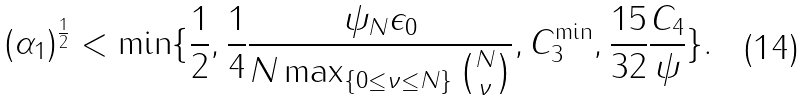<formula> <loc_0><loc_0><loc_500><loc_500>( \alpha _ { 1 } ) ^ { \frac { 1 } { 2 } } < \min \{ \frac { 1 } { 2 } , \frac { 1 } { 4 } \frac { \psi _ { N } \epsilon _ { 0 } } { N \max _ { \{ 0 \leq \nu \leq N \} } \binom { N } { \nu } } , C _ { 3 } ^ { \min } , \frac { 1 5 } { 3 2 } \frac { C _ { 4 } } { \psi } \} .</formula> 